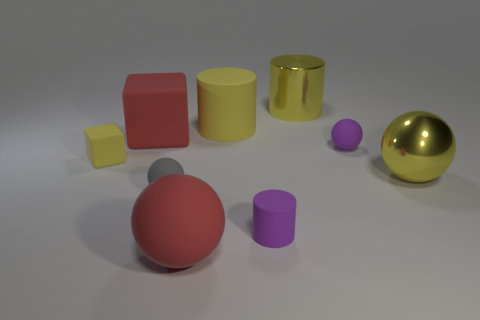Can you tell me the colors of the two largest objects? The two largest objects are a red sphere and a yellow cylinder. 